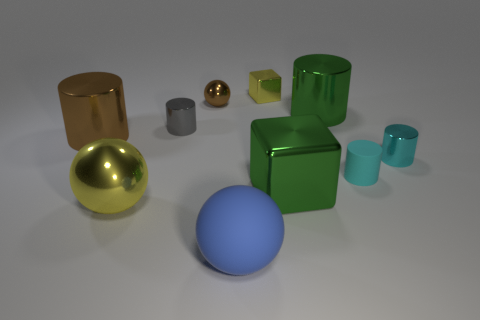Subtract 2 cylinders. How many cylinders are left? 3 Subtract all brown cylinders. How many cylinders are left? 4 Subtract all gray cylinders. How many cylinders are left? 4 Subtract all blue cylinders. Subtract all purple blocks. How many cylinders are left? 5 Subtract all spheres. How many objects are left? 7 Subtract 0 purple blocks. How many objects are left? 10 Subtract all gray metallic objects. Subtract all gray metal cylinders. How many objects are left? 8 Add 7 yellow metal blocks. How many yellow metal blocks are left? 8 Add 3 large green shiny blocks. How many large green shiny blocks exist? 4 